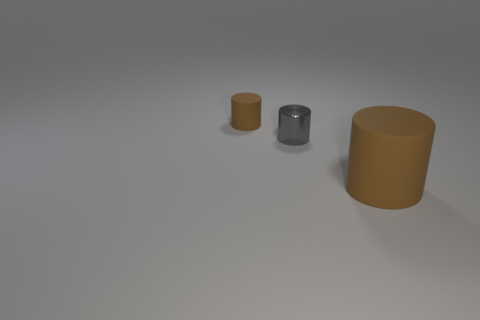What is the shape of the matte object that is the same color as the tiny matte cylinder?
Provide a succinct answer. Cylinder. There is a small thing that is to the left of the metallic cylinder; is it the same shape as the rubber thing that is in front of the small rubber object?
Offer a terse response. Yes. What is the color of the tiny shiny cylinder that is in front of the small brown rubber thing?
Ensure brevity in your answer.  Gray. Are there fewer tiny gray metal cylinders that are right of the large matte cylinder than metallic things that are on the left side of the small metallic cylinder?
Provide a succinct answer. No. What number of other objects are there of the same material as the large thing?
Your response must be concise. 1. Is the tiny brown object made of the same material as the small gray cylinder?
Provide a short and direct response. No. How many other objects are the same size as the metallic object?
Make the answer very short. 1. There is a brown rubber object that is right of the matte thing left of the gray cylinder; what is its size?
Provide a short and direct response. Large. There is a matte cylinder that is in front of the rubber cylinder on the left side of the brown matte object that is in front of the tiny gray cylinder; what is its color?
Offer a very short reply. Brown. What size is the cylinder that is on the right side of the small brown rubber thing and left of the big brown cylinder?
Keep it short and to the point. Small. 